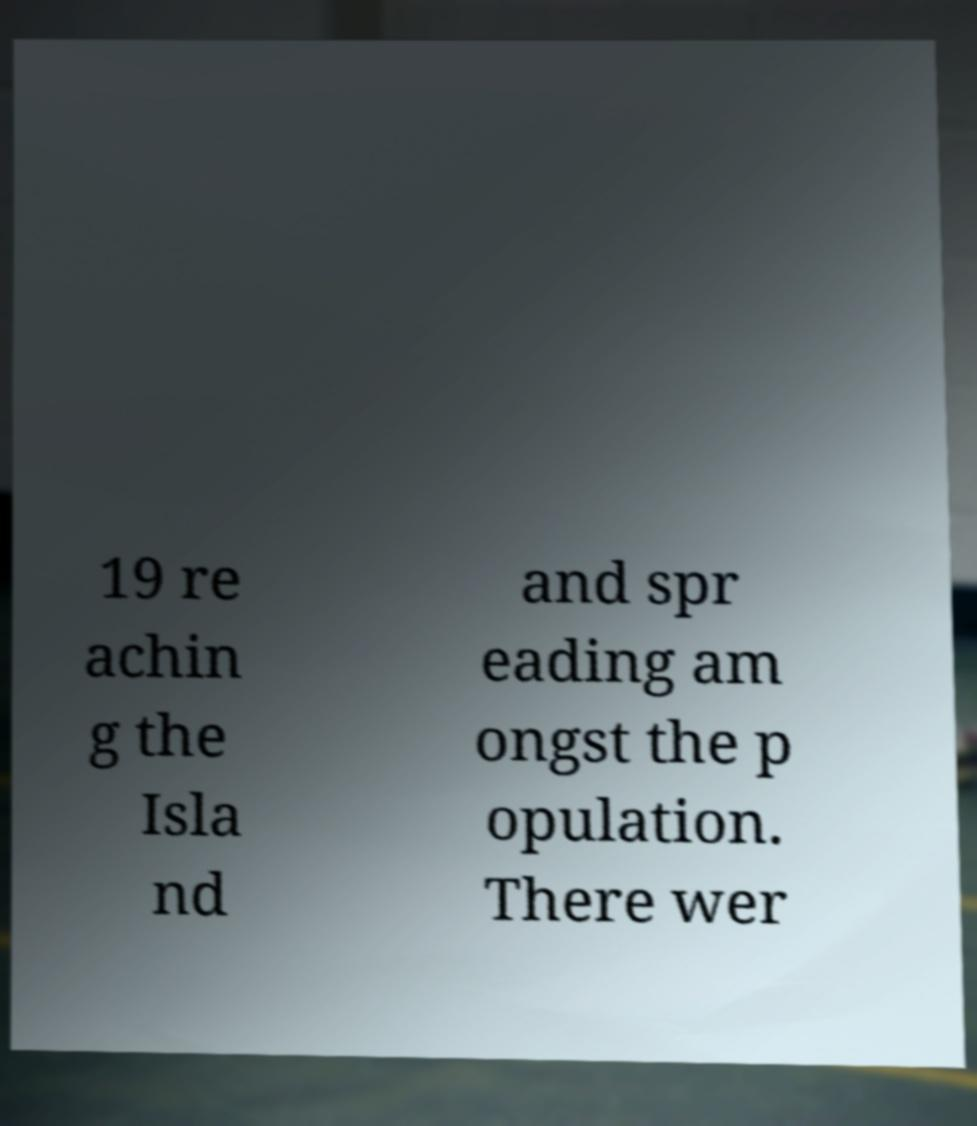Can you read and provide the text displayed in the image?This photo seems to have some interesting text. Can you extract and type it out for me? 19 re achin g the Isla nd and spr eading am ongst the p opulation. There wer 